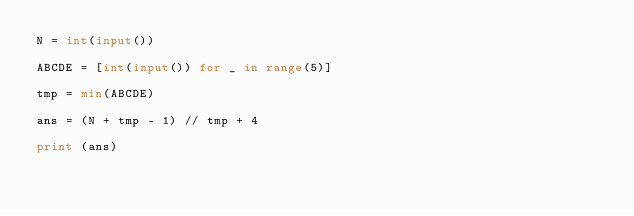<code> <loc_0><loc_0><loc_500><loc_500><_Python_>N = int(input())

ABCDE = [int(input()) for _ in range(5)]

tmp = min(ABCDE)

ans = (N + tmp - 1) // tmp + 4

print (ans)</code> 